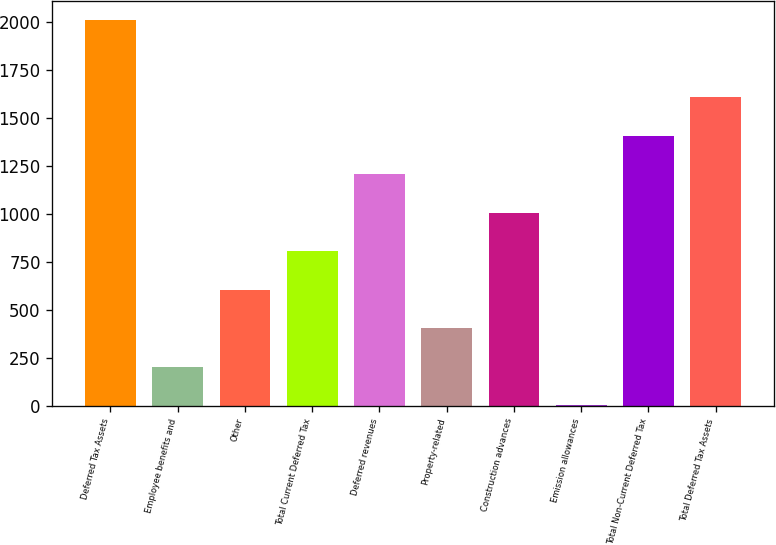<chart> <loc_0><loc_0><loc_500><loc_500><bar_chart><fcel>Deferred Tax Assets<fcel>Employee benefits and<fcel>Other<fcel>Total Current Deferred Tax<fcel>Deferred revenues<fcel>Property-related<fcel>Construction advances<fcel>Emission allowances<fcel>Total Non-Current Deferred Tax<fcel>Total Deferred Tax Assets<nl><fcel>2010<fcel>203.34<fcel>604.82<fcel>805.56<fcel>1207.04<fcel>404.08<fcel>1006.3<fcel>2.6<fcel>1407.78<fcel>1608.52<nl></chart> 